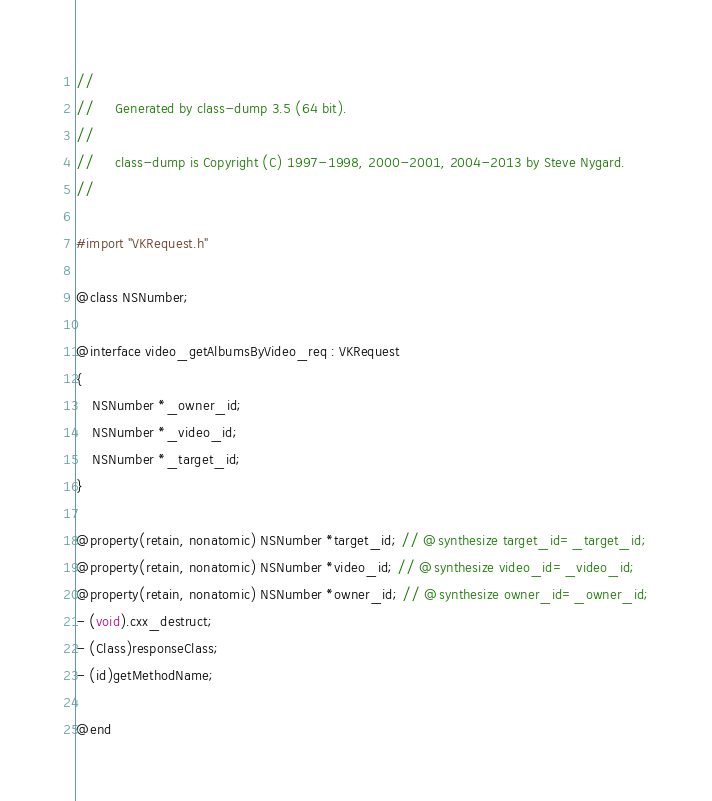<code> <loc_0><loc_0><loc_500><loc_500><_C_>//
//     Generated by class-dump 3.5 (64 bit).
//
//     class-dump is Copyright (C) 1997-1998, 2000-2001, 2004-2013 by Steve Nygard.
//

#import "VKRequest.h"

@class NSNumber;

@interface video_getAlbumsByVideo_req : VKRequest
{
    NSNumber *_owner_id;
    NSNumber *_video_id;
    NSNumber *_target_id;
}

@property(retain, nonatomic) NSNumber *target_id; // @synthesize target_id=_target_id;
@property(retain, nonatomic) NSNumber *video_id; // @synthesize video_id=_video_id;
@property(retain, nonatomic) NSNumber *owner_id; // @synthesize owner_id=_owner_id;
- (void).cxx_destruct;
- (Class)responseClass;
- (id)getMethodName;

@end

</code> 